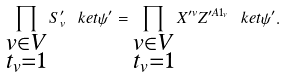Convert formula to latex. <formula><loc_0><loc_0><loc_500><loc_500>\prod _ { \substack { v \in V \\ t _ { v } = 1 } } S ^ { \prime } _ { v } \ k e t { \psi ^ { \prime } } = \prod _ { \substack { v \in V \\ t _ { v } = 1 } } X ^ { \prime v } Z ^ { \prime A 1 _ { v } } \ k e t { \psi ^ { \prime } } .</formula> 